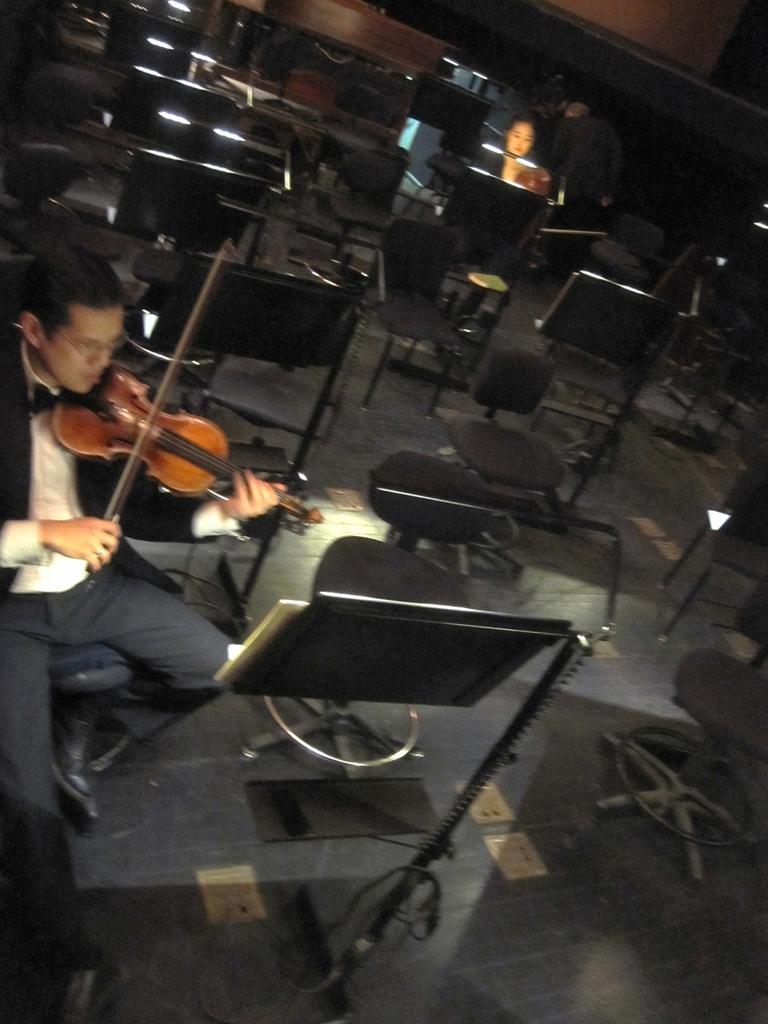Describe this image in one or two sentences. Here a woman is playing violin by looking at the book. In the background there are few people,chairs. 